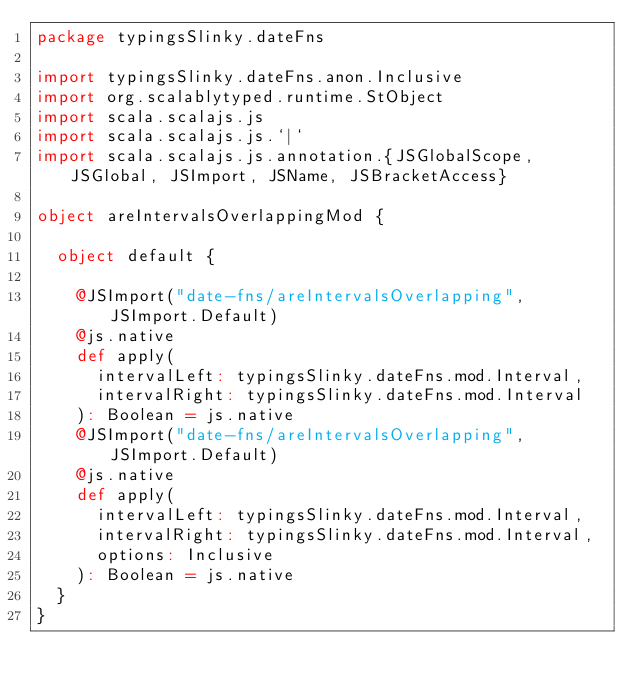<code> <loc_0><loc_0><loc_500><loc_500><_Scala_>package typingsSlinky.dateFns

import typingsSlinky.dateFns.anon.Inclusive
import org.scalablytyped.runtime.StObject
import scala.scalajs.js
import scala.scalajs.js.`|`
import scala.scalajs.js.annotation.{JSGlobalScope, JSGlobal, JSImport, JSName, JSBracketAccess}

object areIntervalsOverlappingMod {
  
  object default {
    
    @JSImport("date-fns/areIntervalsOverlapping", JSImport.Default)
    @js.native
    def apply(
      intervalLeft: typingsSlinky.dateFns.mod.Interval,
      intervalRight: typingsSlinky.dateFns.mod.Interval
    ): Boolean = js.native
    @JSImport("date-fns/areIntervalsOverlapping", JSImport.Default)
    @js.native
    def apply(
      intervalLeft: typingsSlinky.dateFns.mod.Interval,
      intervalRight: typingsSlinky.dateFns.mod.Interval,
      options: Inclusive
    ): Boolean = js.native
  }
}
</code> 